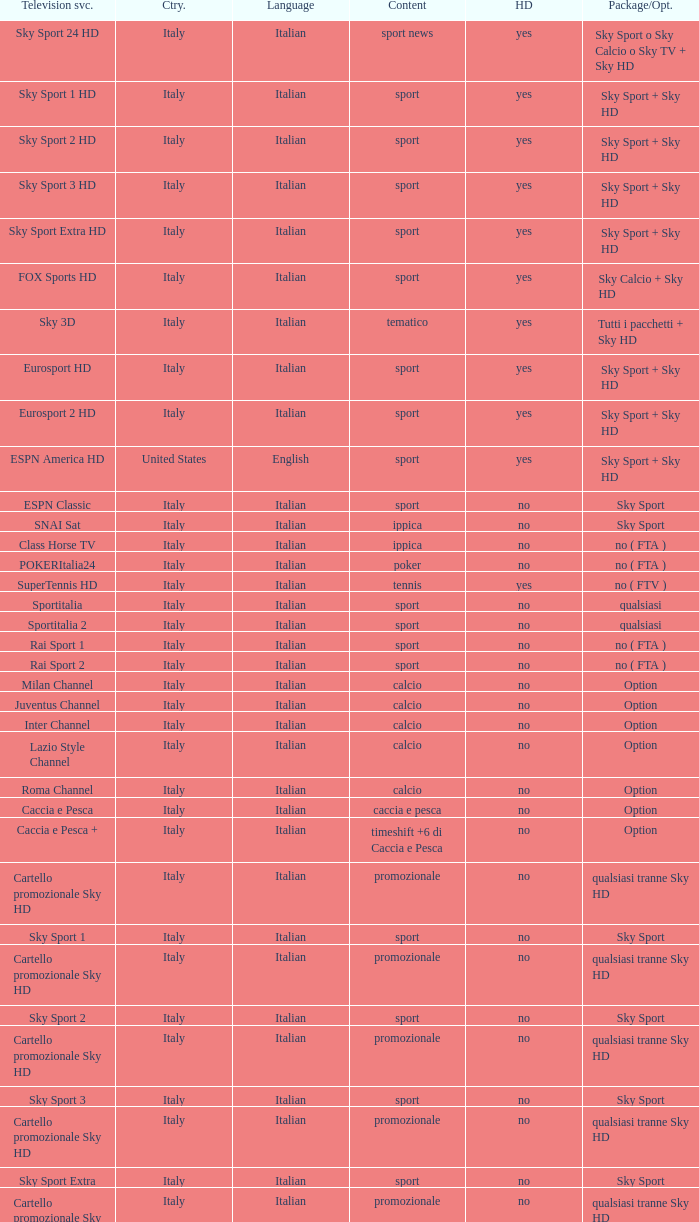What is Television Service, when Content is Calcio, and when Package/Option is Option? Milan Channel, Juventus Channel, Inter Channel, Lazio Style Channel, Roma Channel. Could you parse the entire table as a dict? {'header': ['Television svc.', 'Ctry.', 'Language', 'Content', 'HD', 'Package/Opt.'], 'rows': [['Sky Sport 24 HD', 'Italy', 'Italian', 'sport news', 'yes', 'Sky Sport o Sky Calcio o Sky TV + Sky HD'], ['Sky Sport 1 HD', 'Italy', 'Italian', 'sport', 'yes', 'Sky Sport + Sky HD'], ['Sky Sport 2 HD', 'Italy', 'Italian', 'sport', 'yes', 'Sky Sport + Sky HD'], ['Sky Sport 3 HD', 'Italy', 'Italian', 'sport', 'yes', 'Sky Sport + Sky HD'], ['Sky Sport Extra HD', 'Italy', 'Italian', 'sport', 'yes', 'Sky Sport + Sky HD'], ['FOX Sports HD', 'Italy', 'Italian', 'sport', 'yes', 'Sky Calcio + Sky HD'], ['Sky 3D', 'Italy', 'Italian', 'tematico', 'yes', 'Tutti i pacchetti + Sky HD'], ['Eurosport HD', 'Italy', 'Italian', 'sport', 'yes', 'Sky Sport + Sky HD'], ['Eurosport 2 HD', 'Italy', 'Italian', 'sport', 'yes', 'Sky Sport + Sky HD'], ['ESPN America HD', 'United States', 'English', 'sport', 'yes', 'Sky Sport + Sky HD'], ['ESPN Classic', 'Italy', 'Italian', 'sport', 'no', 'Sky Sport'], ['SNAI Sat', 'Italy', 'Italian', 'ippica', 'no', 'Sky Sport'], ['Class Horse TV', 'Italy', 'Italian', 'ippica', 'no', 'no ( FTA )'], ['POKERItalia24', 'Italy', 'Italian', 'poker', 'no', 'no ( FTA )'], ['SuperTennis HD', 'Italy', 'Italian', 'tennis', 'yes', 'no ( FTV )'], ['Sportitalia', 'Italy', 'Italian', 'sport', 'no', 'qualsiasi'], ['Sportitalia 2', 'Italy', 'Italian', 'sport', 'no', 'qualsiasi'], ['Rai Sport 1', 'Italy', 'Italian', 'sport', 'no', 'no ( FTA )'], ['Rai Sport 2', 'Italy', 'Italian', 'sport', 'no', 'no ( FTA )'], ['Milan Channel', 'Italy', 'Italian', 'calcio', 'no', 'Option'], ['Juventus Channel', 'Italy', 'Italian', 'calcio', 'no', 'Option'], ['Inter Channel', 'Italy', 'Italian', 'calcio', 'no', 'Option'], ['Lazio Style Channel', 'Italy', 'Italian', 'calcio', 'no', 'Option'], ['Roma Channel', 'Italy', 'Italian', 'calcio', 'no', 'Option'], ['Caccia e Pesca', 'Italy', 'Italian', 'caccia e pesca', 'no', 'Option'], ['Caccia e Pesca +', 'Italy', 'Italian', 'timeshift +6 di Caccia e Pesca', 'no', 'Option'], ['Cartello promozionale Sky HD', 'Italy', 'Italian', 'promozionale', 'no', 'qualsiasi tranne Sky HD'], ['Sky Sport 1', 'Italy', 'Italian', 'sport', 'no', 'Sky Sport'], ['Cartello promozionale Sky HD', 'Italy', 'Italian', 'promozionale', 'no', 'qualsiasi tranne Sky HD'], ['Sky Sport 2', 'Italy', 'Italian', 'sport', 'no', 'Sky Sport'], ['Cartello promozionale Sky HD', 'Italy', 'Italian', 'promozionale', 'no', 'qualsiasi tranne Sky HD'], ['Sky Sport 3', 'Italy', 'Italian', 'sport', 'no', 'Sky Sport'], ['Cartello promozionale Sky HD', 'Italy', 'Italian', 'promozionale', 'no', 'qualsiasi tranne Sky HD'], ['Sky Sport Extra', 'Italy', 'Italian', 'sport', 'no', 'Sky Sport'], ['Cartello promozionale Sky HD', 'Italy', 'Italian', 'promozionale', 'no', 'qualsiasi tranne Sky HD'], ['Sky Supercalcio', 'Italy', 'Italian', 'calcio', 'no', 'Sky Calcio'], ['Cartello promozionale Sky HD', 'Italy', 'Italian', 'promozionale', 'no', 'qualsiasi tranne Sky HD'], ['Eurosport', 'Italy', 'Italian', 'sport', 'no', 'Sky Sport'], ['Eurosport 2', 'Italy', 'Italian', 'sport', 'no', 'Sky Sport'], ['ESPN America', 'Italy', 'Italian', 'sport', 'no', 'Sky Sport']]} 